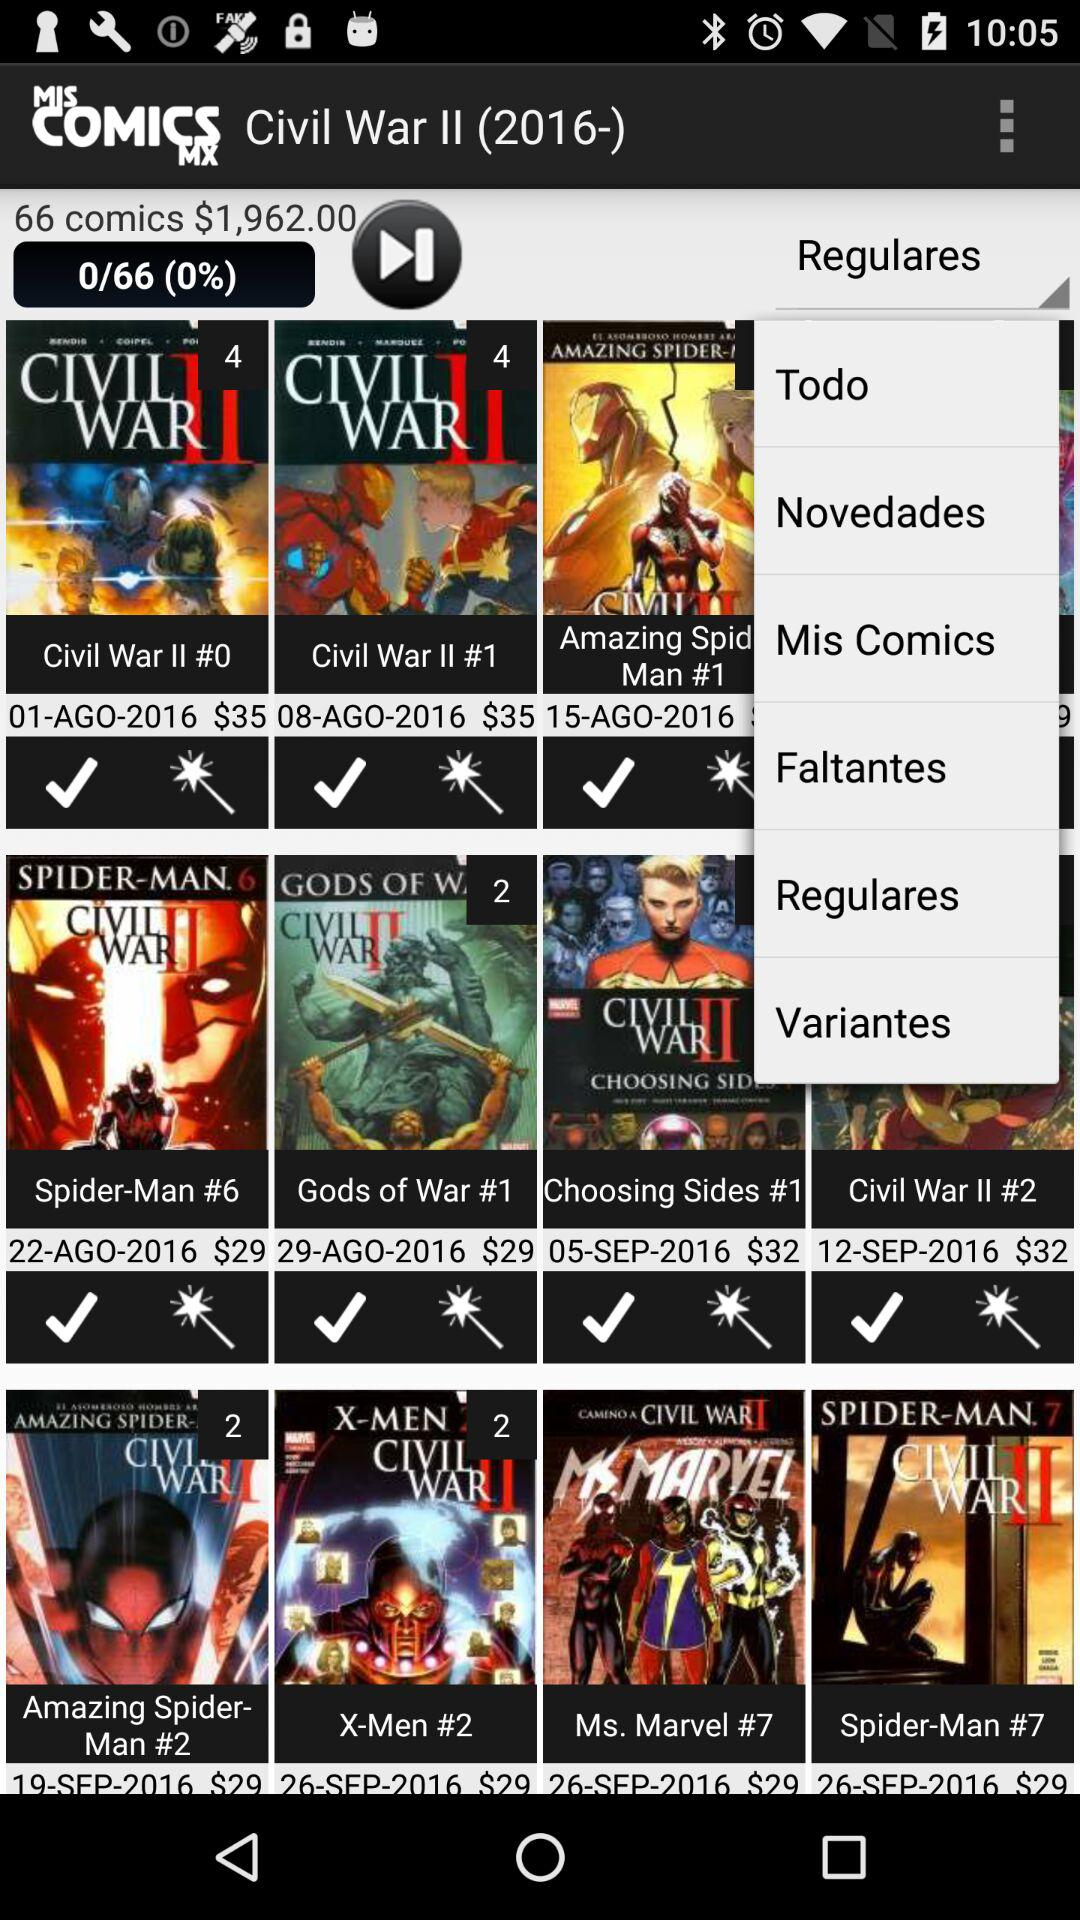What are the names of the comics? The names of the comics are "Civil War II #0", "Civil War II #1", "Spider-Man #6", "Gods of War #1", "Choosing Sides #1", "Civil War II #2", "Amazing Spider-Man #2", "X-Men #2", "Ms. Marvel #7" and "Spider-Man #7". 